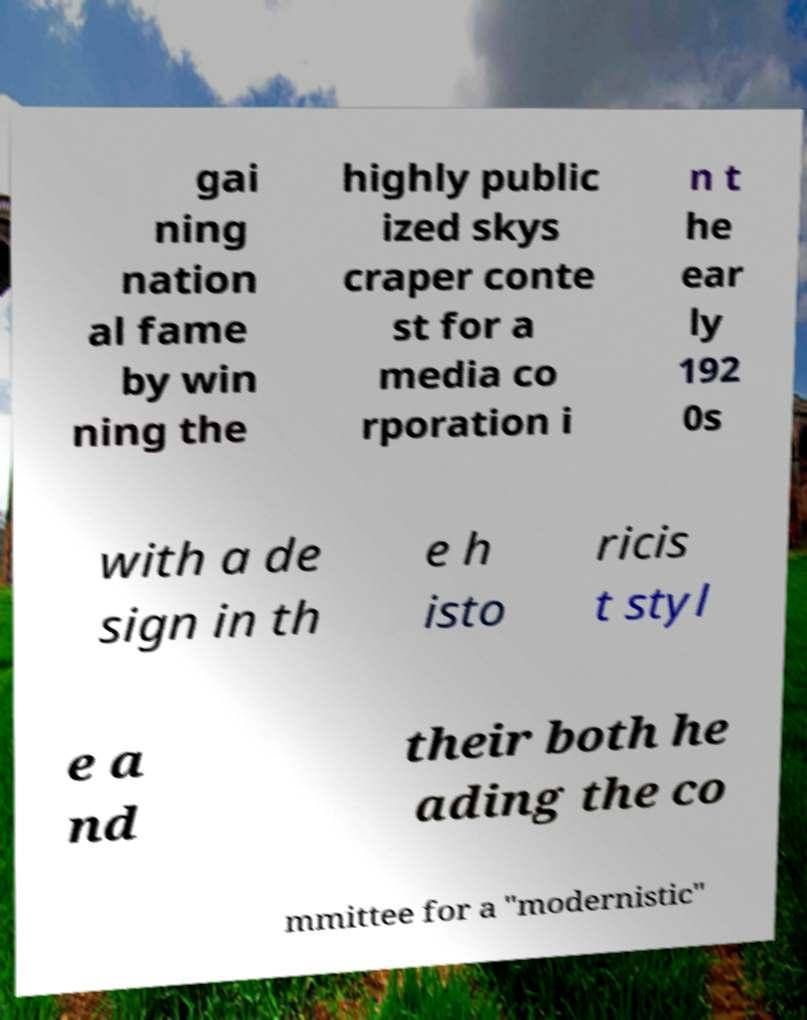Could you assist in decoding the text presented in this image and type it out clearly? gai ning nation al fame by win ning the highly public ized skys craper conte st for a media co rporation i n t he ear ly 192 0s with a de sign in th e h isto ricis t styl e a nd their both he ading the co mmittee for a "modernistic" 